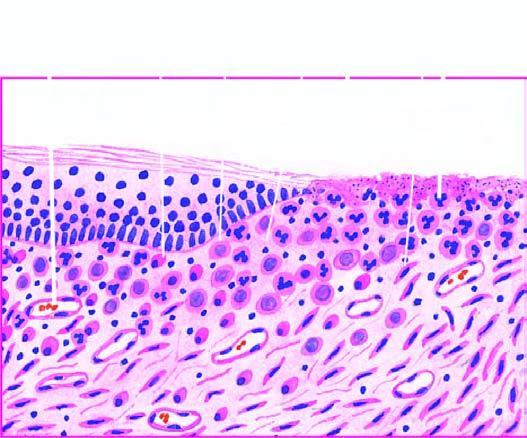what does ctive granulation tissue have?
Answer the question using a single word or phrase. Inflammatory cell infiltrate 